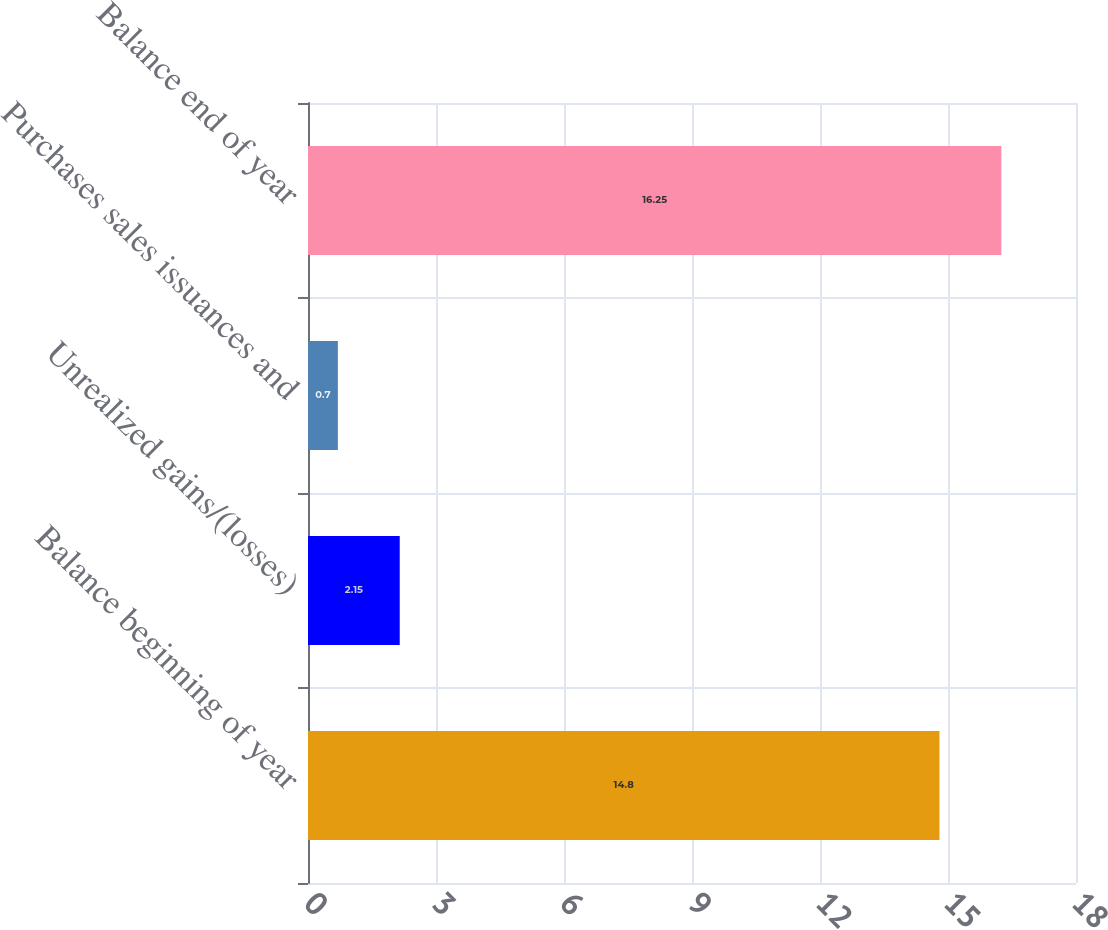<chart> <loc_0><loc_0><loc_500><loc_500><bar_chart><fcel>Balance beginning of year<fcel>Unrealized gains/(losses)<fcel>Purchases sales issuances and<fcel>Balance end of year<nl><fcel>14.8<fcel>2.15<fcel>0.7<fcel>16.25<nl></chart> 